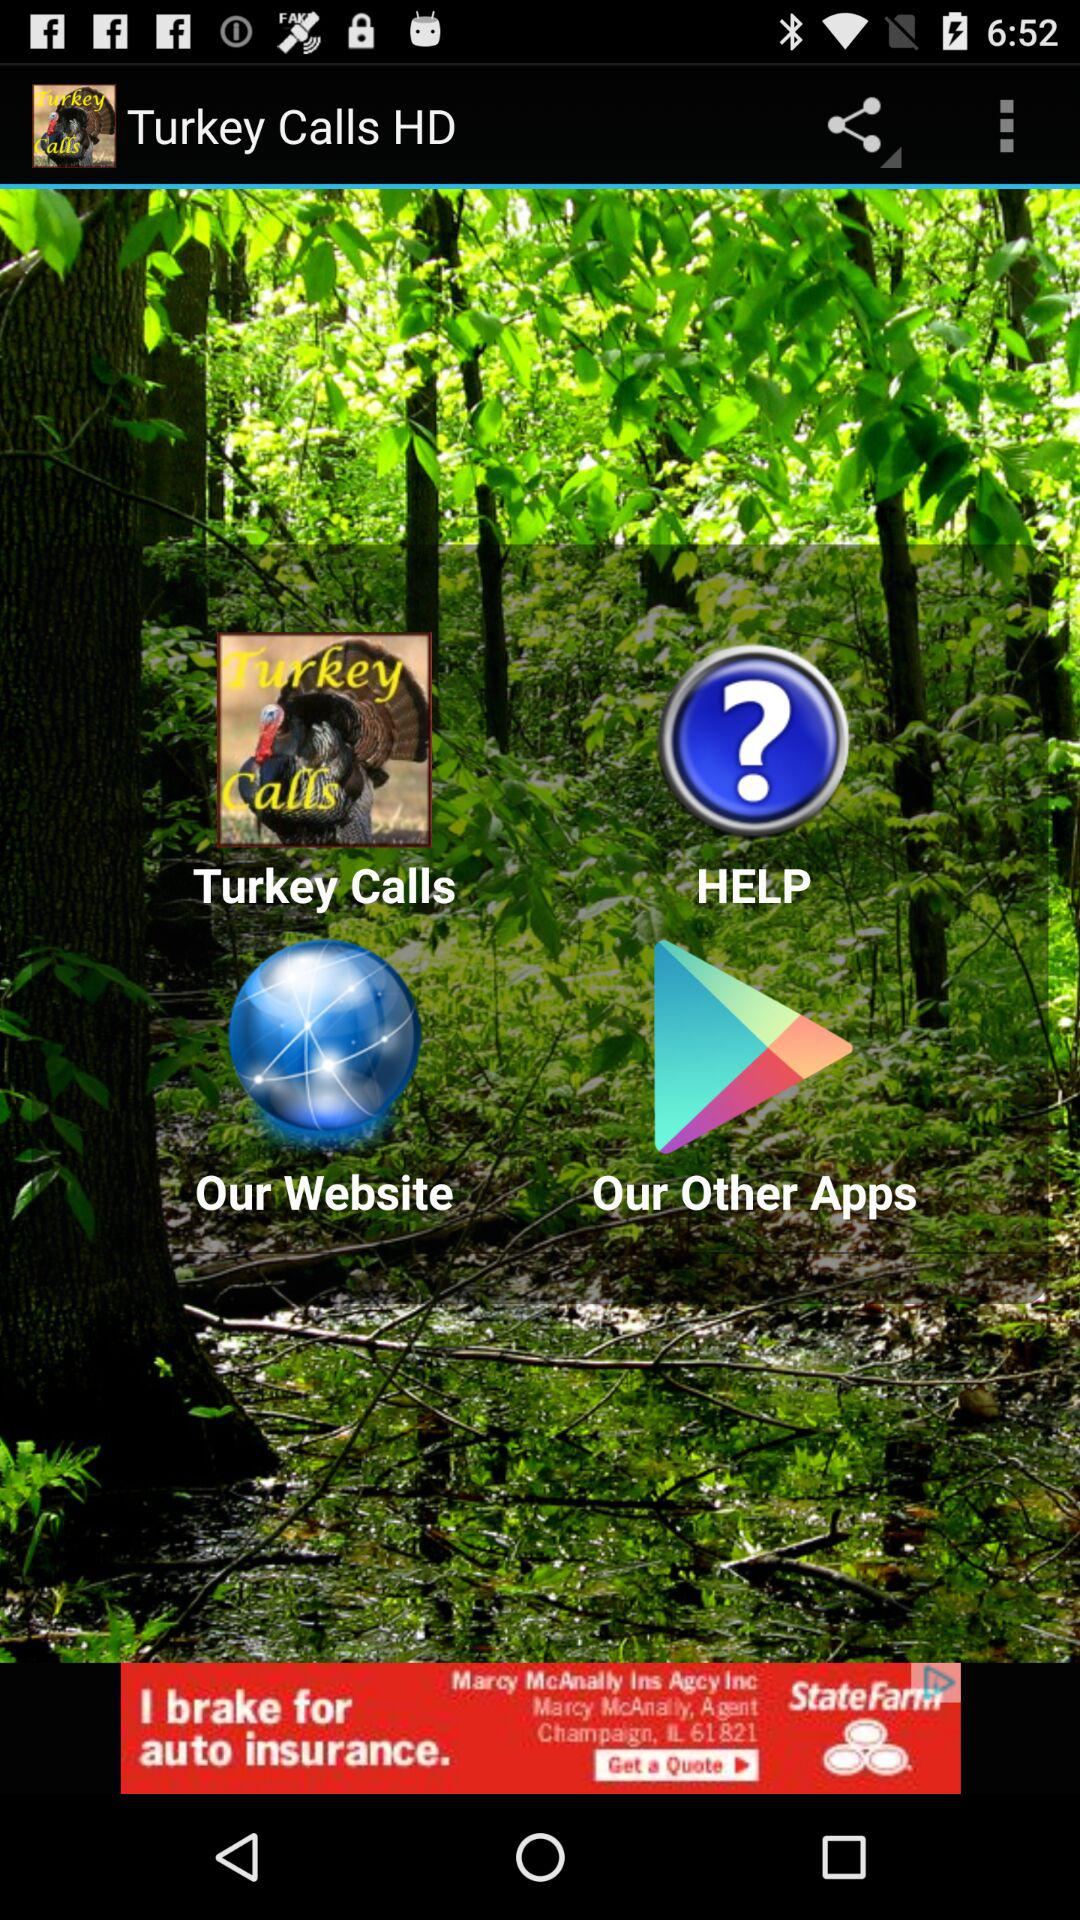How many other apps are available?
When the provided information is insufficient, respond with <no answer>. <no answer> 